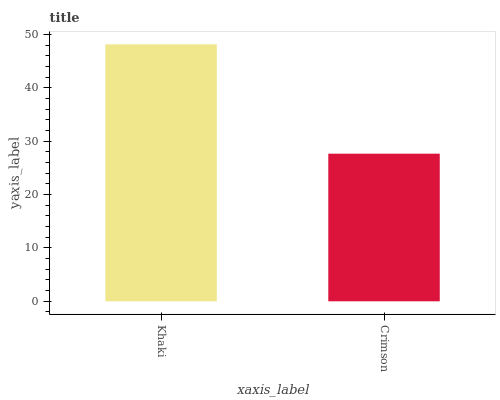Is Crimson the minimum?
Answer yes or no. Yes. Is Khaki the maximum?
Answer yes or no. Yes. Is Crimson the maximum?
Answer yes or no. No. Is Khaki greater than Crimson?
Answer yes or no. Yes. Is Crimson less than Khaki?
Answer yes or no. Yes. Is Crimson greater than Khaki?
Answer yes or no. No. Is Khaki less than Crimson?
Answer yes or no. No. Is Khaki the high median?
Answer yes or no. Yes. Is Crimson the low median?
Answer yes or no. Yes. Is Crimson the high median?
Answer yes or no. No. Is Khaki the low median?
Answer yes or no. No. 